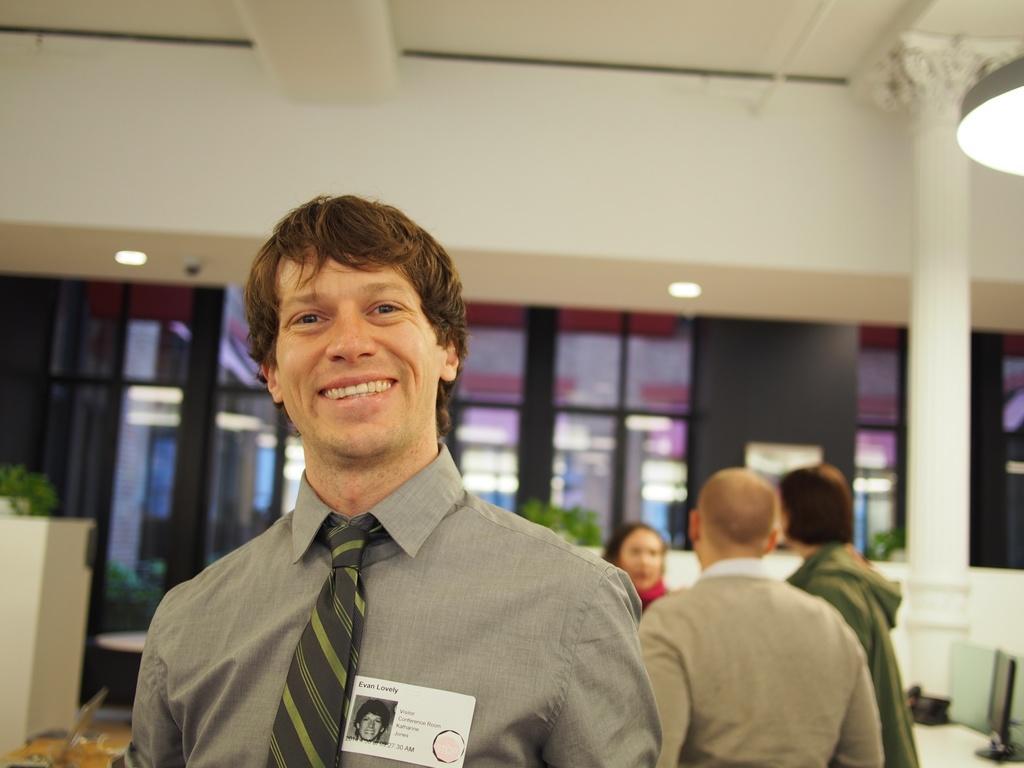How would you summarize this image in a sentence or two? In this image I can see the group of people with different color dresses. I can see these people are inside the building. In the background I can see the plants and the pillar. I can see the lights at the top. 